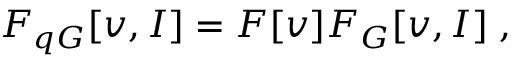Convert formula to latex. <formula><loc_0><loc_0><loc_500><loc_500>F _ { q G } [ v , I ] = F [ v ] F _ { G } [ v , I ] \, ,</formula> 